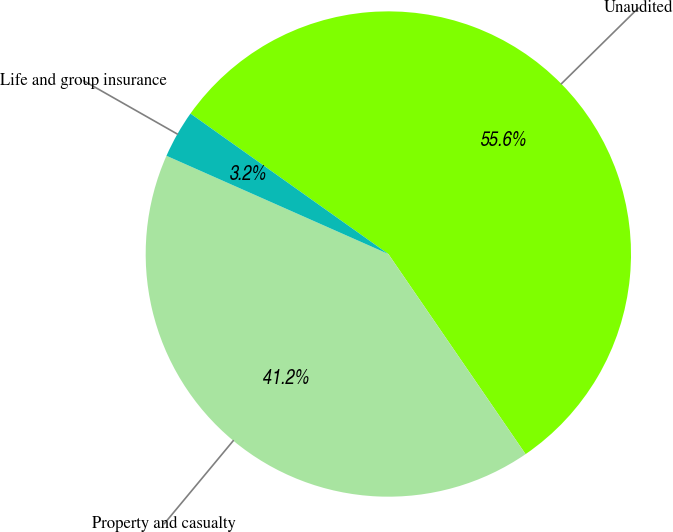Convert chart. <chart><loc_0><loc_0><loc_500><loc_500><pie_chart><fcel>Unaudited<fcel>Property and casualty<fcel>Life and group insurance<nl><fcel>55.61%<fcel>41.2%<fcel>3.19%<nl></chart> 